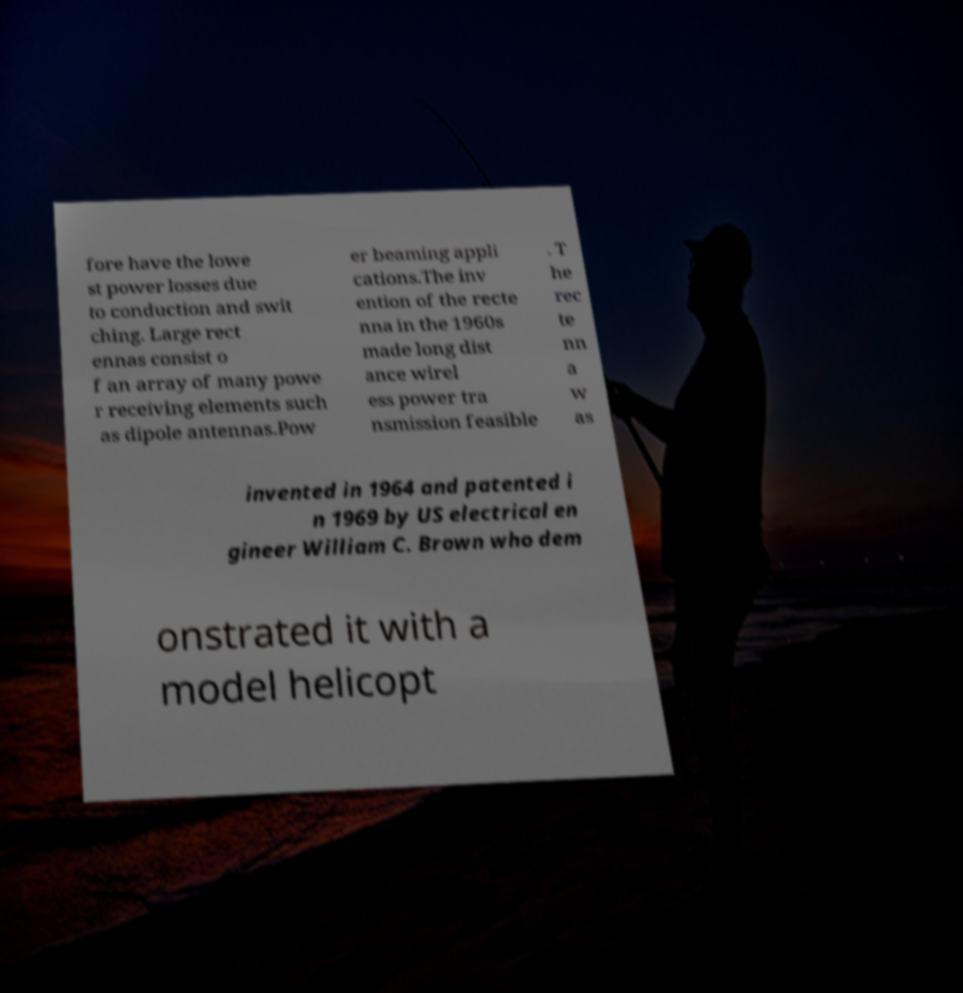Could you extract and type out the text from this image? fore have the lowe st power losses due to conduction and swit ching. Large rect ennas consist o f an array of many powe r receiving elements such as dipole antennas.Pow er beaming appli cations.The inv ention of the recte nna in the 1960s made long dist ance wirel ess power tra nsmission feasible . T he rec te nn a w as invented in 1964 and patented i n 1969 by US electrical en gineer William C. Brown who dem onstrated it with a model helicopt 